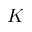<formula> <loc_0><loc_0><loc_500><loc_500>K</formula> 